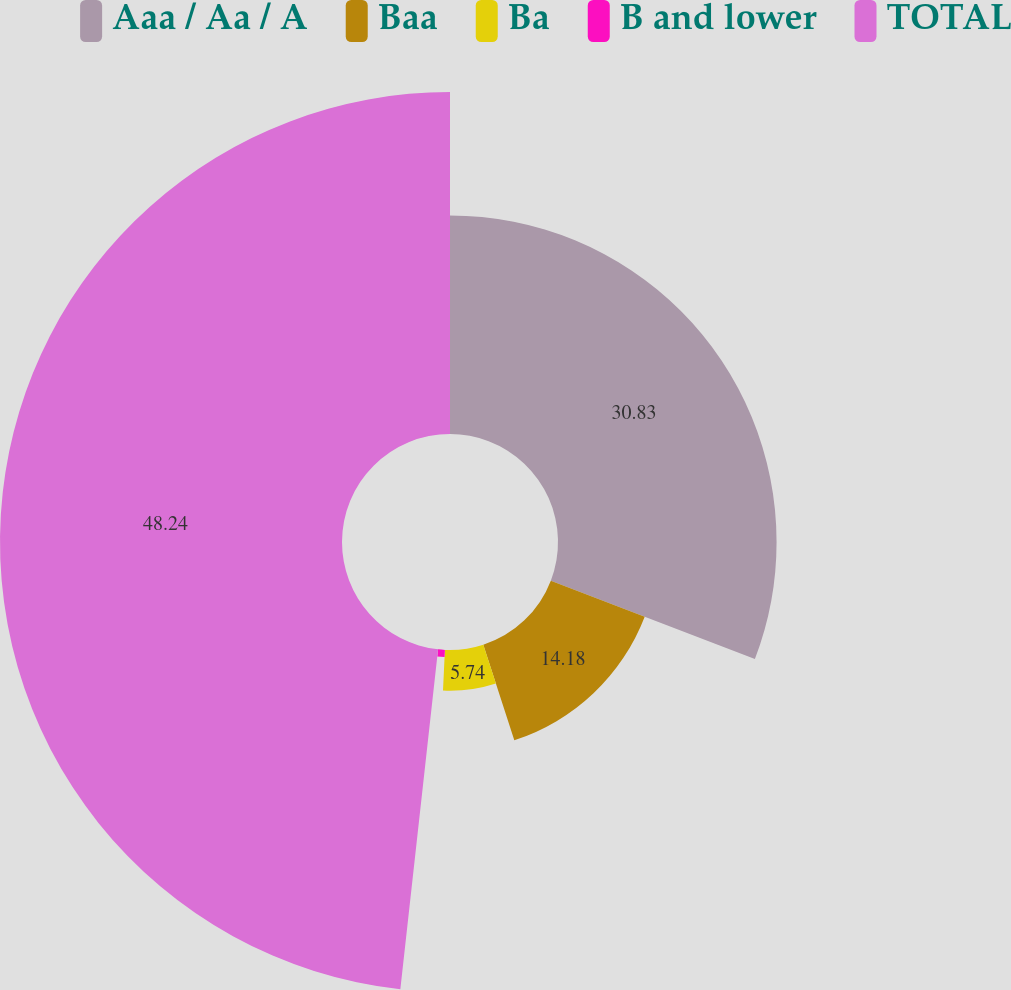Convert chart to OTSL. <chart><loc_0><loc_0><loc_500><loc_500><pie_chart><fcel>Aaa / Aa / A<fcel>Baa<fcel>Ba<fcel>B and lower<fcel>TOTAL<nl><fcel>30.83%<fcel>14.18%<fcel>5.74%<fcel>1.01%<fcel>48.24%<nl></chart> 